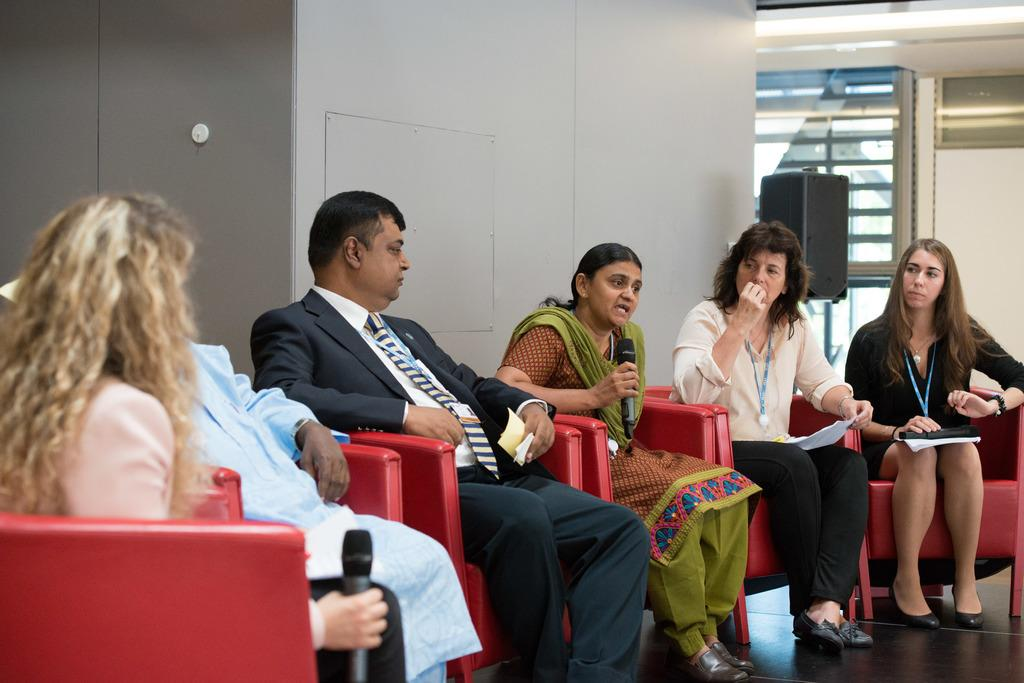What are the people in the image doing? The persons sitting on chairs in the image are likely engaged in a meeting or discussion. What can be seen in the background of the image? There is a speaker, a window, and a wall in the background of the image. What type of copper material is present in the image? There is no copper material present in the image. What mark can be seen on the wall in the image? There is no mark visible on the wall in the image. 